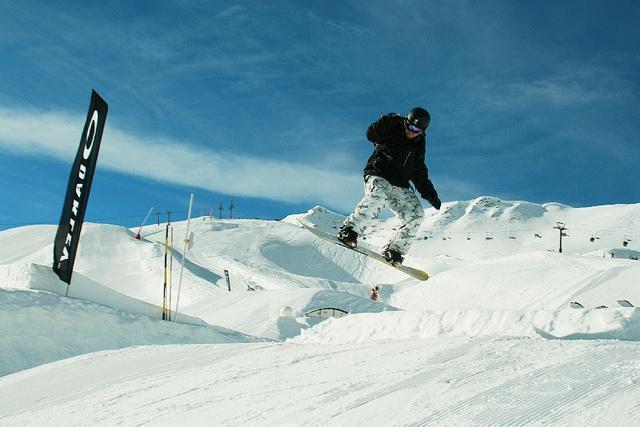Why is the black banner most likely flying in the snowboarder's location?
Indicate the correct choice and explain in the format: 'Answer: answer
Rationale: rationale.'
Options: Shade, decoration, warning, advertisement. Answer: advertisement.
Rationale: The banner is an ad. 